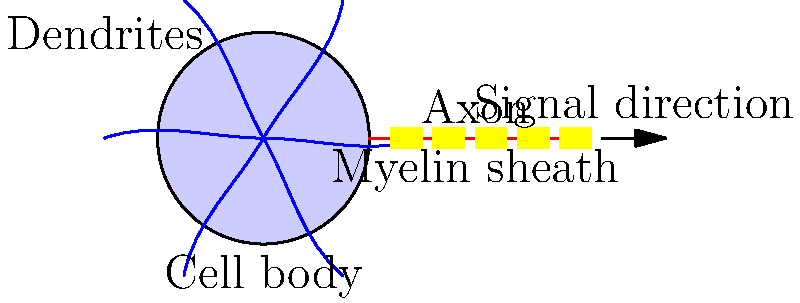In the diagram of a neuron, which structure receives signals from other neurons and is characterized by its branching appearance? To answer this question, let's examine the different parts of the neuron shown in the diagram:

1. Cell body: This is the central, spherical structure of the neuron. It contains the nucleus and other organelles, but it doesn't have a branching appearance.

2. Axon: This is the long, thin projection extending from the cell body. It's responsible for transmitting signals to other neurons, but it doesn't receive signals and doesn't have a branching appearance.

3. Myelin sheath: This is the insulating layer around the axon, shown as segmented yellow blocks. It doesn't receive signals and isn't branched.

4. Dendrites: These are the multiple short, branching structures extending from the cell body. They have a characteristic tree-like or branching appearance.

The dendrites are specifically designed to receive signals from other neurons. Their branching structure increases the surface area, allowing for more connections with other neurons and more efficient signal reception.

Therefore, the structure that receives signals from other neurons and is characterized by its branching appearance is the dendrites.
Answer: Dendrites 